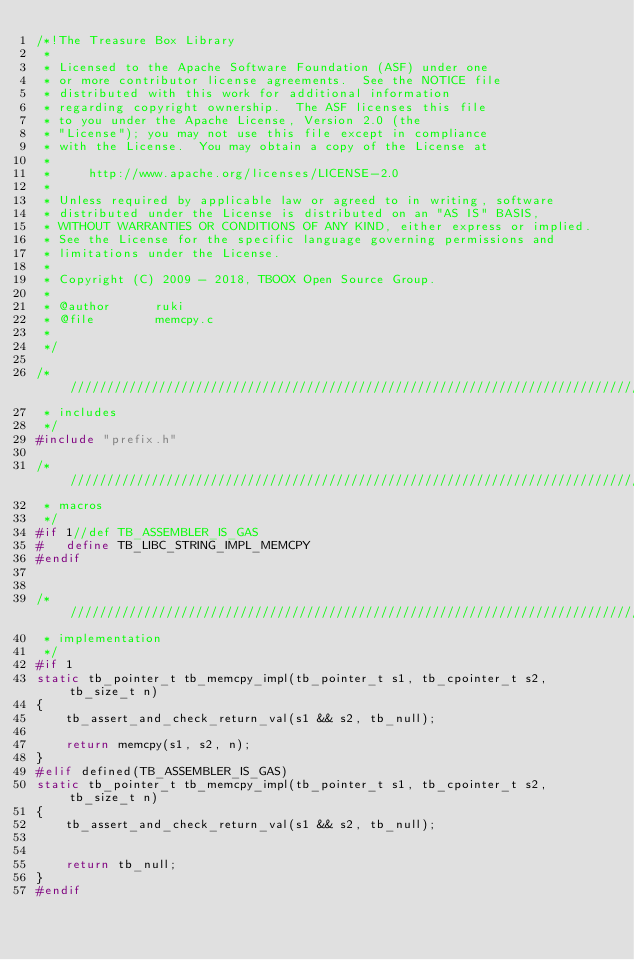<code> <loc_0><loc_0><loc_500><loc_500><_C_>/*!The Treasure Box Library
 *
 * Licensed to the Apache Software Foundation (ASF) under one
 * or more contributor license agreements.  See the NOTICE file
 * distributed with this work for additional information
 * regarding copyright ownership.  The ASF licenses this file
 * to you under the Apache License, Version 2.0 (the
 * "License"); you may not use this file except in compliance
 * with the License.  You may obtain a copy of the License at
 *
 *     http://www.apache.org/licenses/LICENSE-2.0
 *
 * Unless required by applicable law or agreed to in writing, software
 * distributed under the License is distributed on an "AS IS" BASIS,
 * WITHOUT WARRANTIES OR CONDITIONS OF ANY KIND, either express or implied.
 * See the License for the specific language governing permissions and
 * limitations under the License.
 * 
 * Copyright (C) 2009 - 2018, TBOOX Open Source Group.
 *
 * @author      ruki
 * @file        memcpy.c
 *
 */

/* //////////////////////////////////////////////////////////////////////////////////////
 * includes
 */
#include "prefix.h"

/* //////////////////////////////////////////////////////////////////////////////////////
 * macros
 */
#if 1//def TB_ASSEMBLER_IS_GAS
#   define TB_LIBC_STRING_IMPL_MEMCPY
#endif


/* //////////////////////////////////////////////////////////////////////////////////////
 * implementation
 */
#if 1
static tb_pointer_t tb_memcpy_impl(tb_pointer_t s1, tb_cpointer_t s2, tb_size_t n)
{
    tb_assert_and_check_return_val(s1 && s2, tb_null);

    return memcpy(s1, s2, n);
}
#elif defined(TB_ASSEMBLER_IS_GAS)
static tb_pointer_t tb_memcpy_impl(tb_pointer_t s1, tb_cpointer_t s2, tb_size_t n)
{
    tb_assert_and_check_return_val(s1 && s2, tb_null);

    
    return tb_null;
}
#endif
</code> 